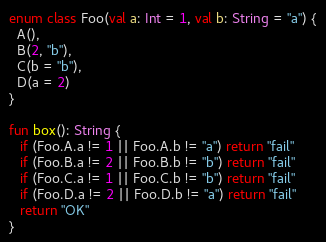Convert code to text. <code><loc_0><loc_0><loc_500><loc_500><_Kotlin_>enum class Foo(val a: Int = 1, val b: String = "a") {
  A(),
  B(2, "b"),
  C(b = "b"),
  D(a = 2)
}

fun box(): String {
   if (Foo.A.a != 1 || Foo.A.b != "a") return "fail"
   if (Foo.B.a != 2 || Foo.B.b != "b") return "fail"
   if (Foo.C.a != 1 || Foo.C.b != "b") return "fail"
   if (Foo.D.a != 2 || Foo.D.b != "a") return "fail"
   return "OK"
}
</code> 